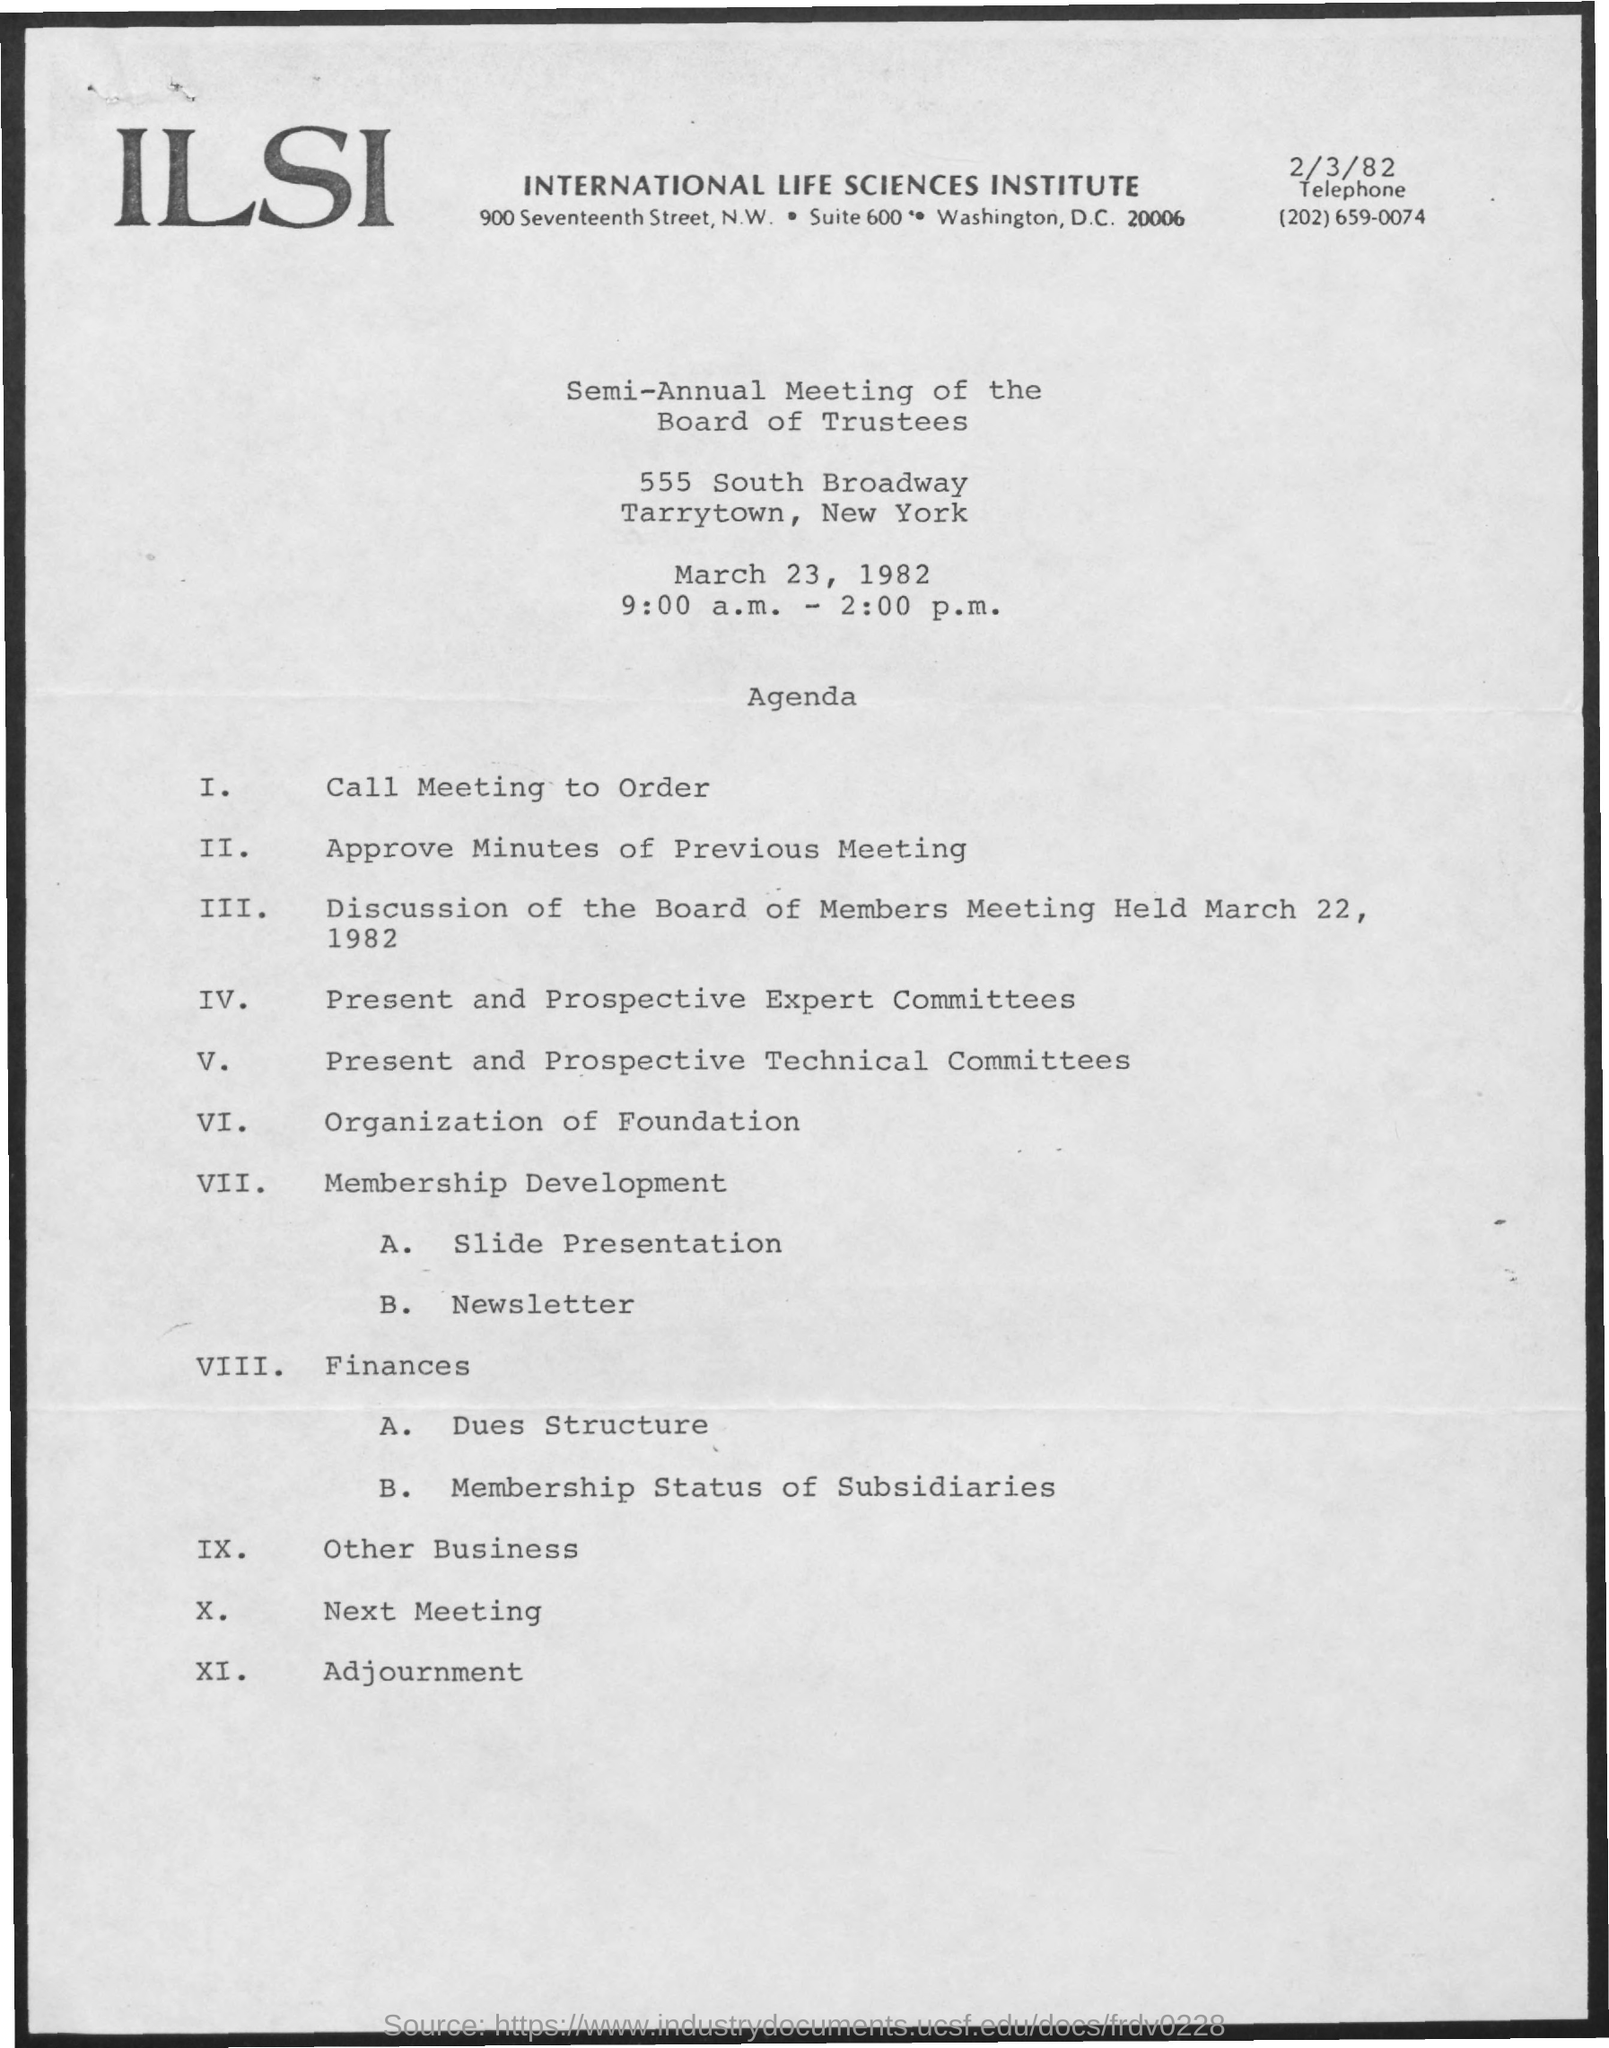Mention a couple of crucial points in this snapshot. The meeting is scheduled for March 23, 1982. The full form of ILSI is the International Life Sciences Institute. 